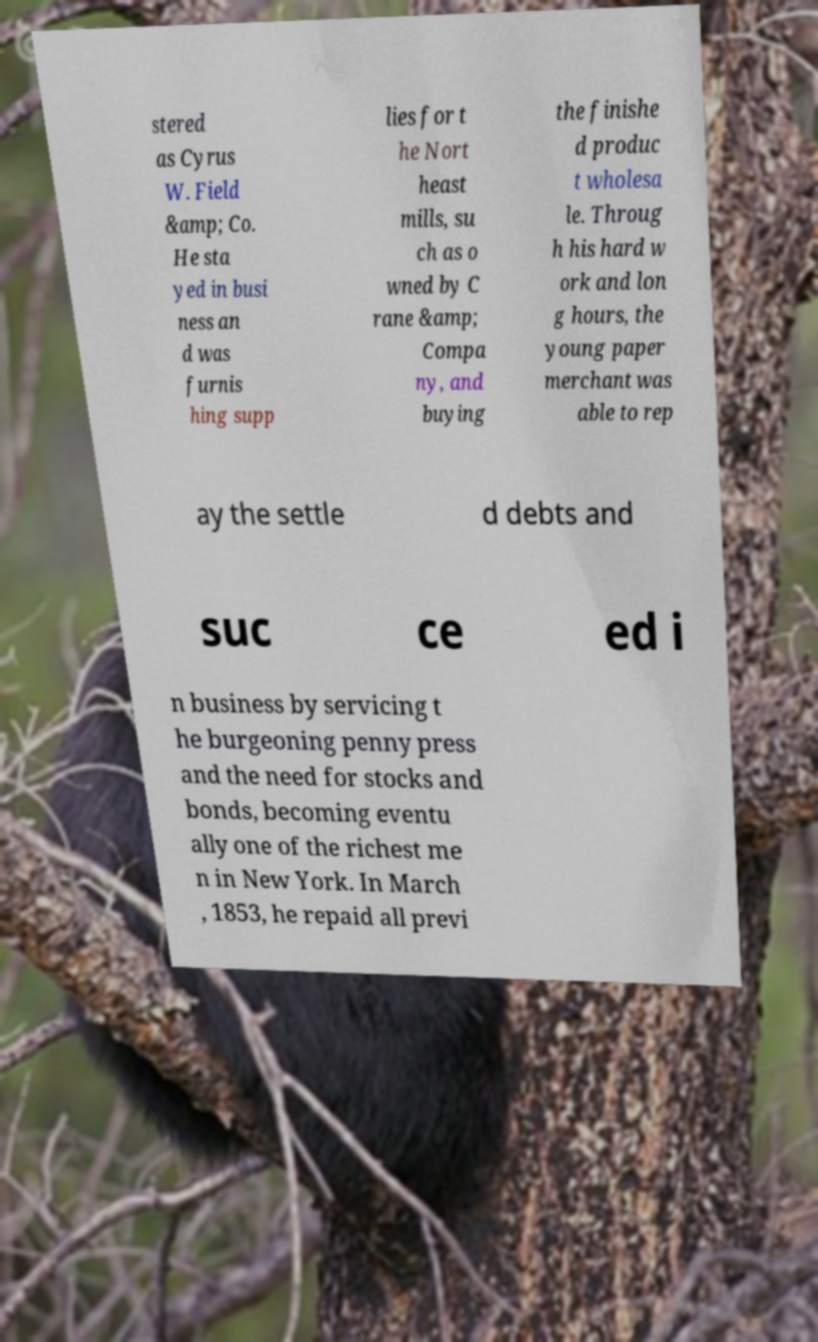I need the written content from this picture converted into text. Can you do that? stered as Cyrus W. Field &amp; Co. He sta yed in busi ness an d was furnis hing supp lies for t he Nort heast mills, su ch as o wned by C rane &amp; Compa ny, and buying the finishe d produc t wholesa le. Throug h his hard w ork and lon g hours, the young paper merchant was able to rep ay the settle d debts and suc ce ed i n business by servicing t he burgeoning penny press and the need for stocks and bonds, becoming eventu ally one of the richest me n in New York. In March , 1853, he repaid all previ 